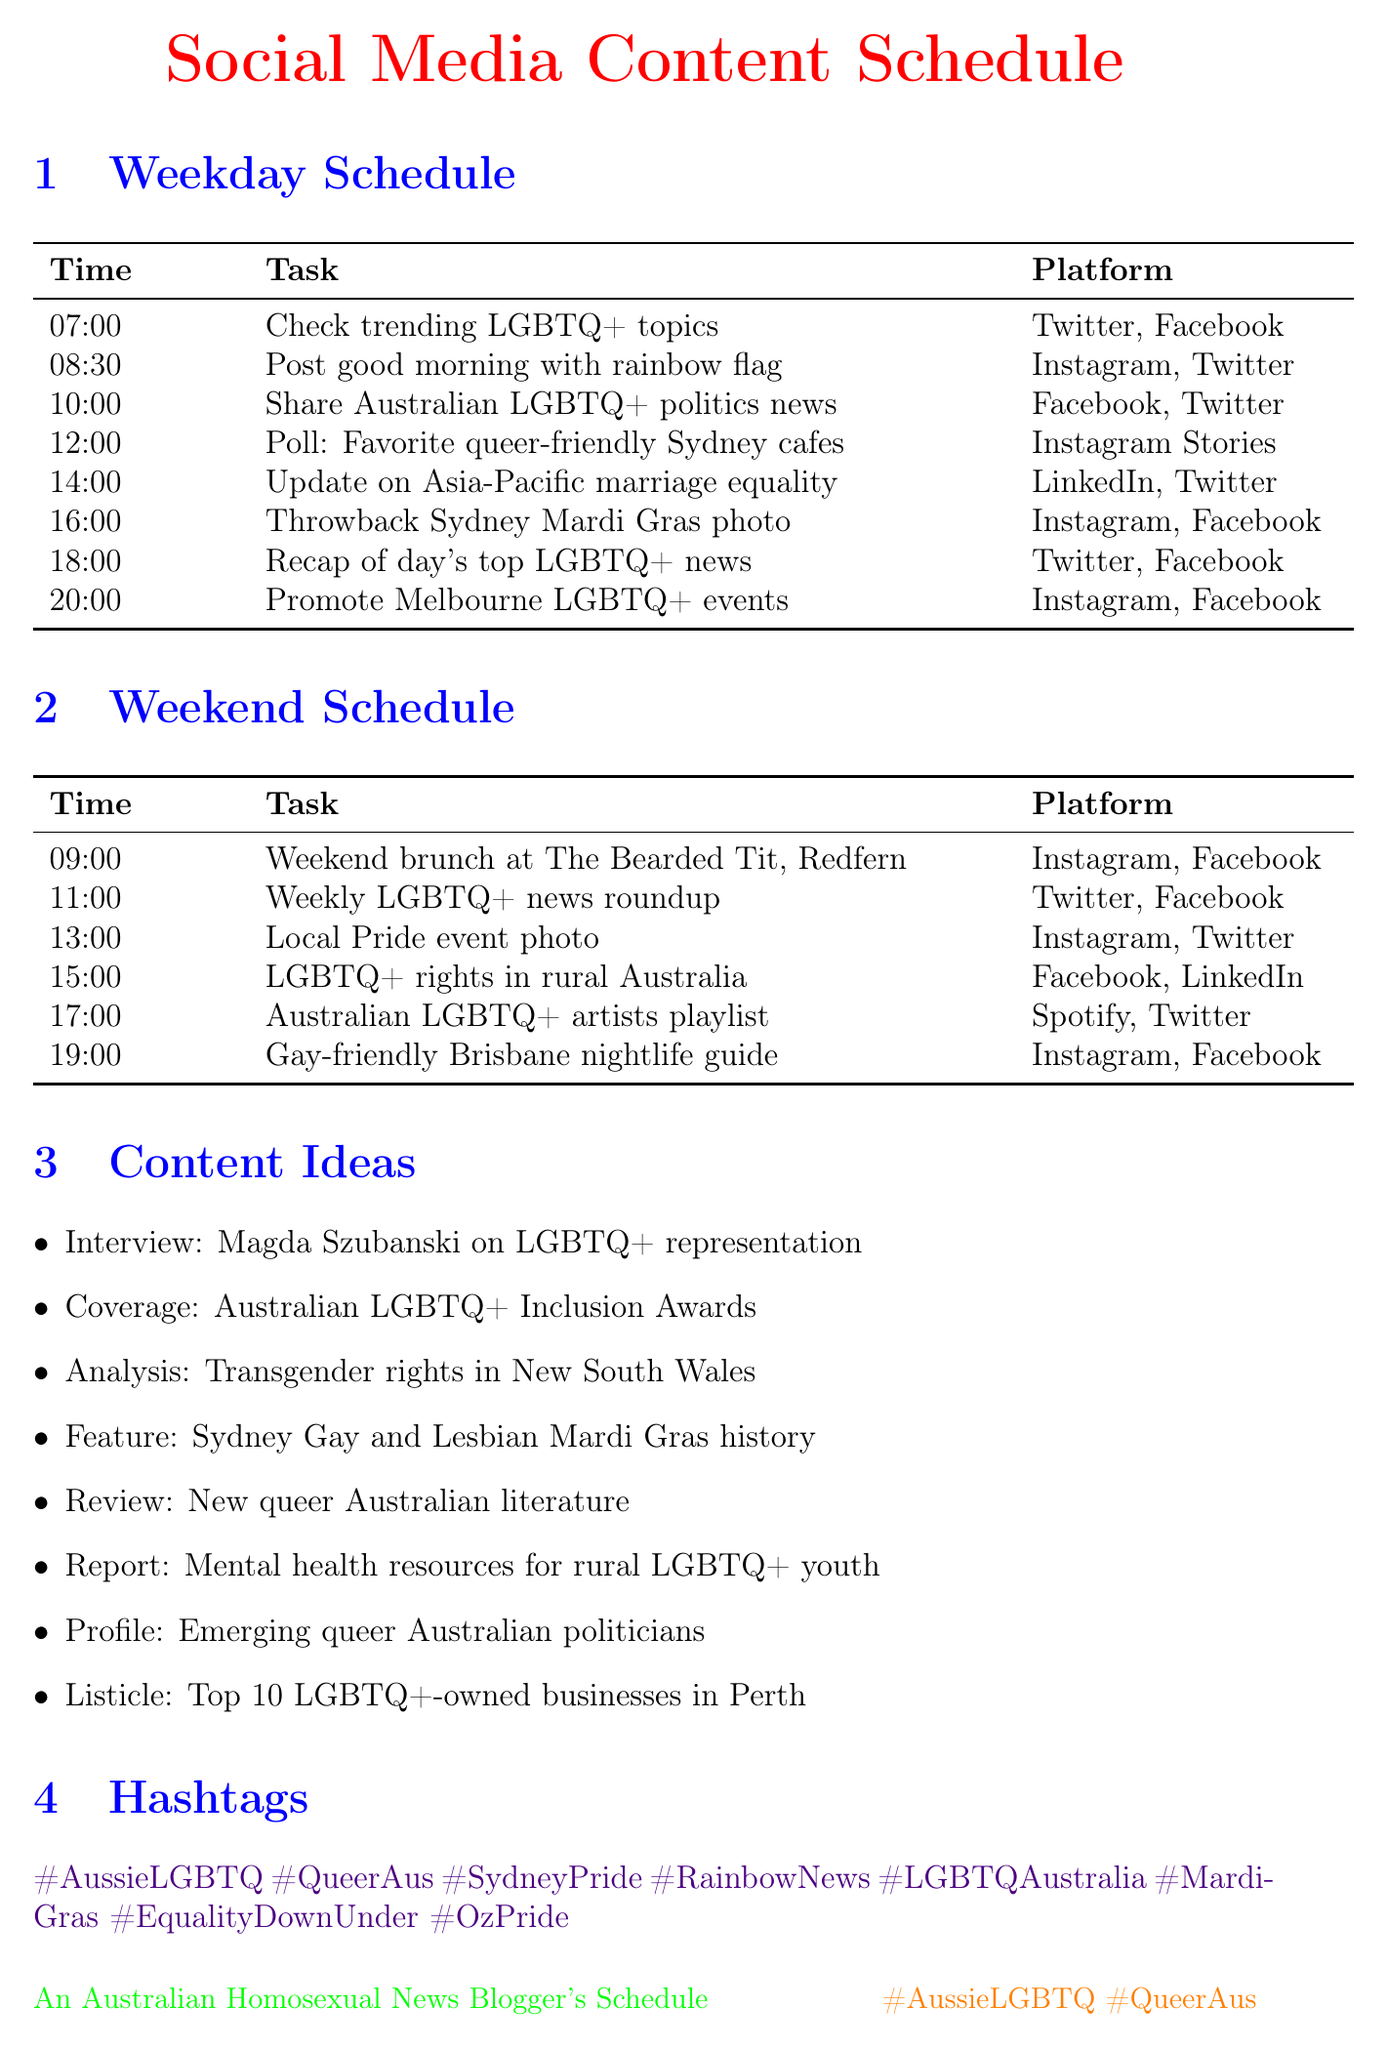What time is the lunch-time poll scheduled? The lunch-time poll task is scheduled for 12:00 in the weekday schedule.
Answer: 12:00 What type of content is shared at 14:00 on weekdays? At 14:00, a news analysis update on marriage equality progress is shared on LinkedIn and Twitter.
Answer: News Analysis How many LGBTQ+ hashtags are listed in the document? The document lists a total of eight LGBTQ+ hashtags related to the content.
Answer: 8 What platform is used for the weekend brunch recommendation? The weekend brunch recommendation is shared on Instagram and Facebook.
Answer: Instagram, Facebook What is the last task scheduled on the weekend? The last task scheduled on the weekend is about gay-friendly nightlife spots in Brisbane at 19:00.
Answer: Nightlife Guide Which platform is designated for sharing music playlists? The platform designated for sharing the playlist of Australian LGBTQ+ artists is Spotify and Twitter.
Answer: Spotify, Twitter What type of content is created at 18:00 on weekdays? At 18:00, a recap of the day's top LGBTQ+ news stories is created.
Answer: News Roundup Which city is specifically mentioned for promoting events on weekdays? The city mentioned for promoting upcoming events is Melbourne.
Answer: Melbourne 